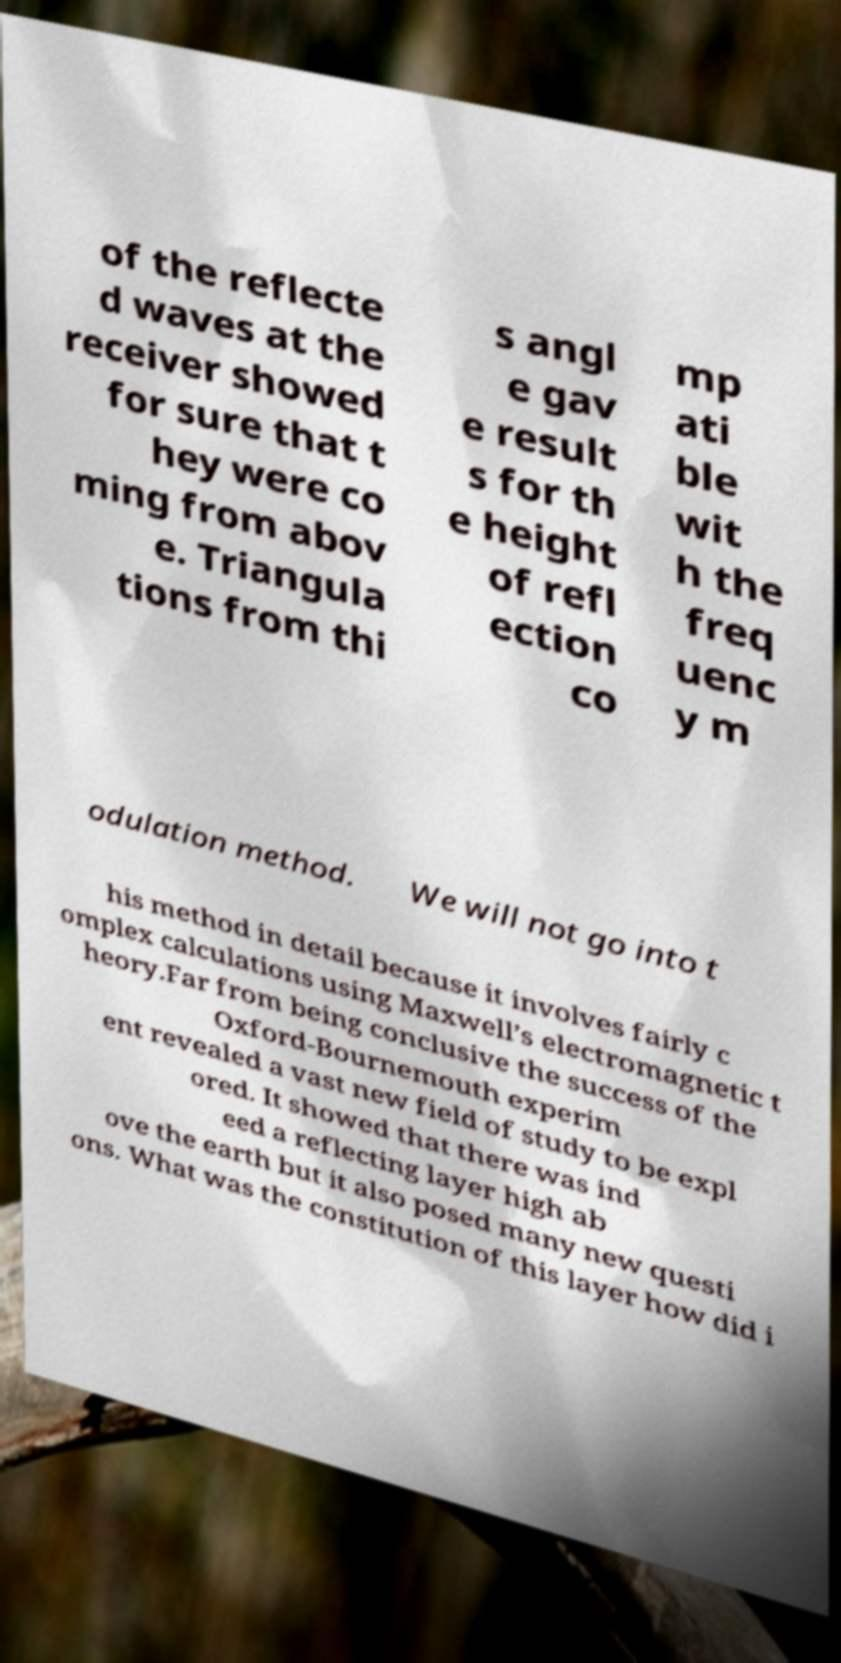What messages or text are displayed in this image? I need them in a readable, typed format. of the reflecte d waves at the receiver showed for sure that t hey were co ming from abov e. Triangula tions from thi s angl e gav e result s for th e height of refl ection co mp ati ble wit h the freq uenc y m odulation method. We will not go into t his method in detail because it involves fairly c omplex calculations using Maxwell’s electromagnetic t heory.Far from being conclusive the success of the Oxford-Bournemouth experim ent revealed a vast new field of study to be expl ored. It showed that there was ind eed a reflecting layer high ab ove the earth but it also posed many new questi ons. What was the constitution of this layer how did i 